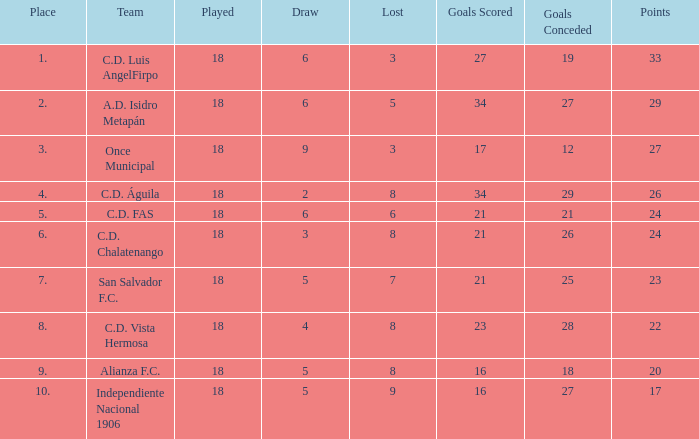Could you parse the entire table? {'header': ['Place', 'Team', 'Played', 'Draw', 'Lost', 'Goals Scored', 'Goals Conceded', 'Points'], 'rows': [['1.', 'C.D. Luis AngelFirpo', '18', '6', '3', '27', '19', '33'], ['2.', 'A.D. Isidro Metapán', '18', '6', '5', '34', '27', '29'], ['3.', 'Once Municipal', '18', '9', '3', '17', '12', '27'], ['4.', 'C.D. Águila', '18', '2', '8', '34', '29', '26'], ['5.', 'C.D. FAS', '18', '6', '6', '21', '21', '24'], ['6.', 'C.D. Chalatenango', '18', '3', '8', '21', '26', '24'], ['7.', 'San Salvador F.C.', '18', '5', '7', '21', '25', '23'], ['8.', 'C.D. Vista Hermosa', '18', '4', '8', '23', '28', '22'], ['9.', 'Alianza F.C.', '18', '5', '8', '16', '18', '20'], ['10.', 'Independiente Nacional 1906', '18', '5', '9', '16', '27', '17']]} In a game where 5 points were lost, more than 2 were placed, and 27 goals conceded, what was the total number of points? 0.0. 